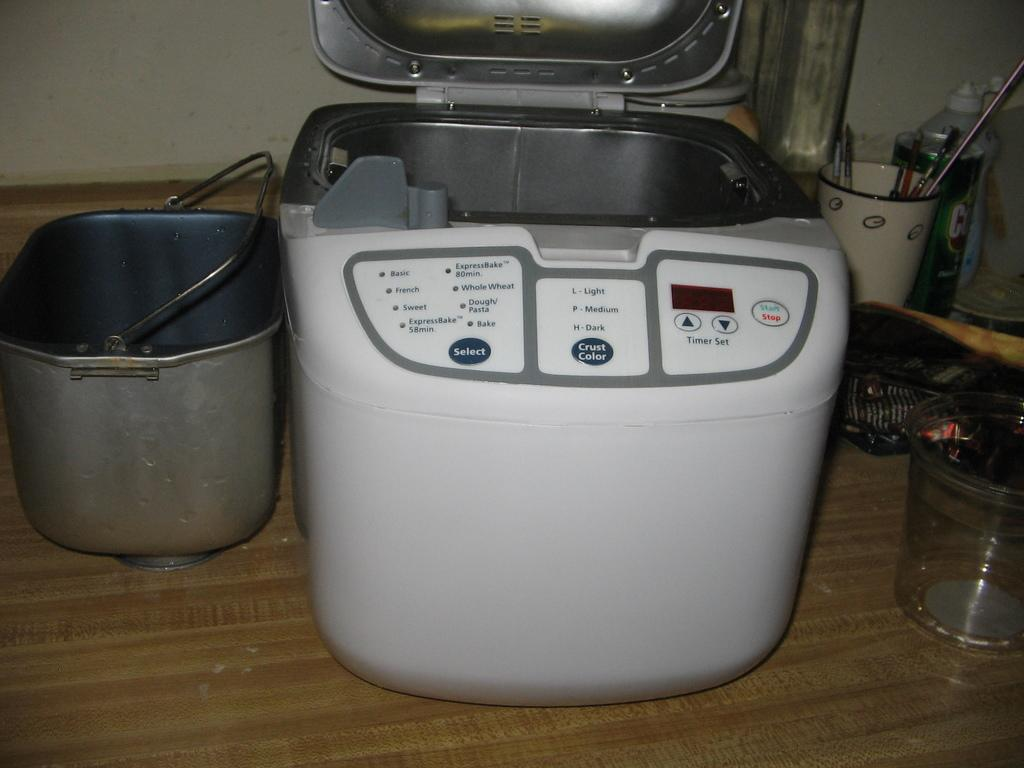<image>
Summarize the visual content of the image. A picture of a bread machine with several settings including Basic, French and Sweet. 